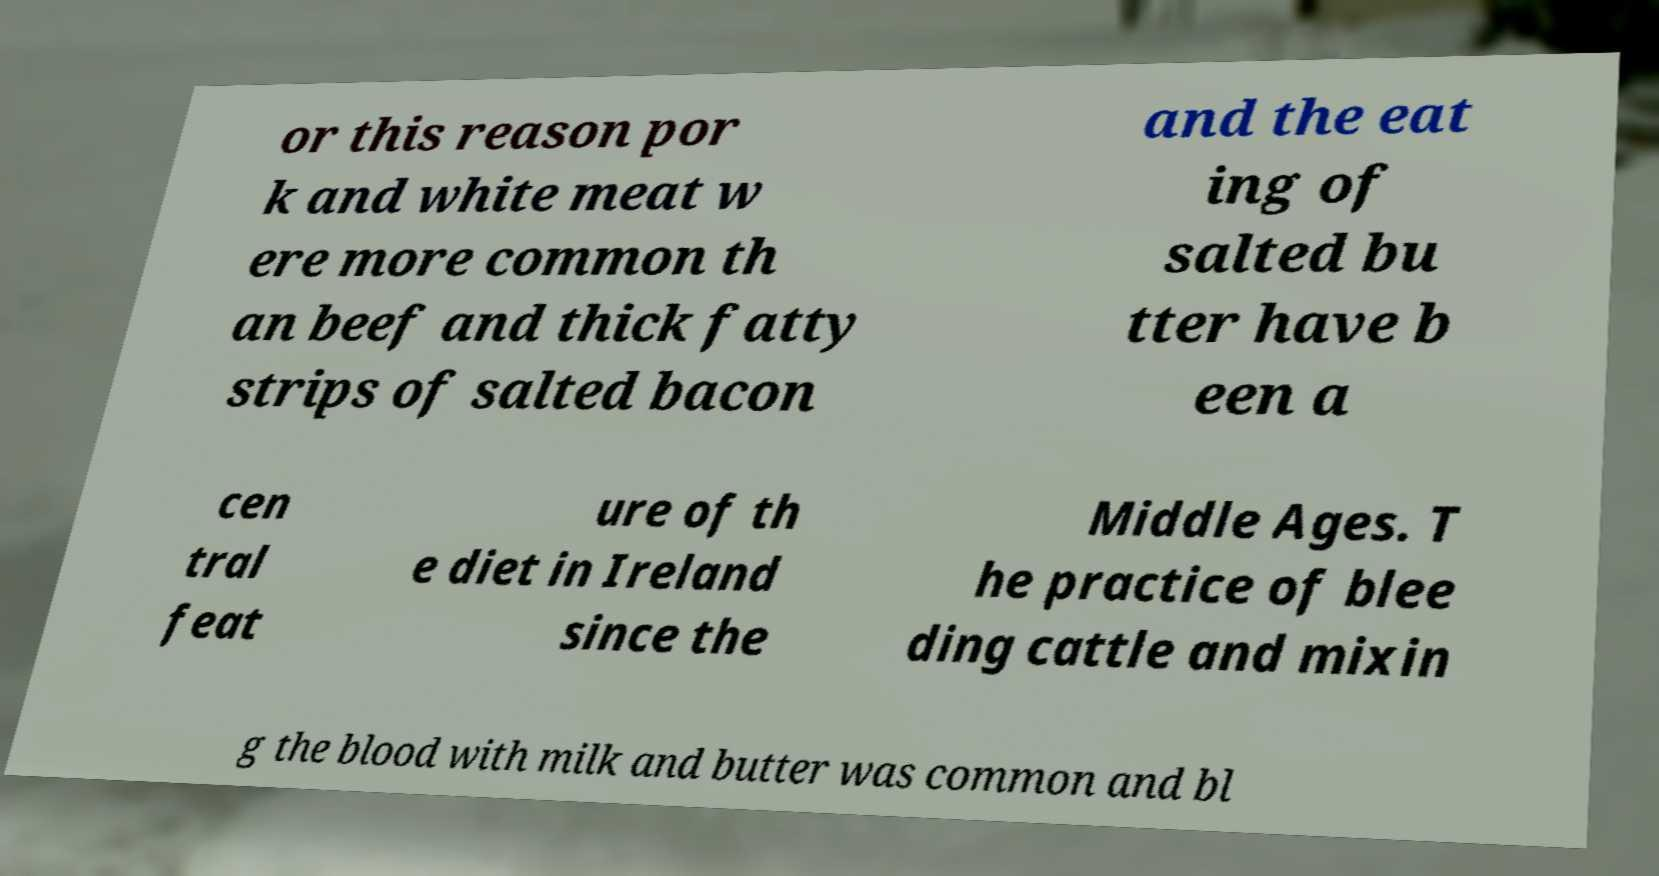What messages or text are displayed in this image? I need them in a readable, typed format. or this reason por k and white meat w ere more common th an beef and thick fatty strips of salted bacon and the eat ing of salted bu tter have b een a cen tral feat ure of th e diet in Ireland since the Middle Ages. T he practice of blee ding cattle and mixin g the blood with milk and butter was common and bl 